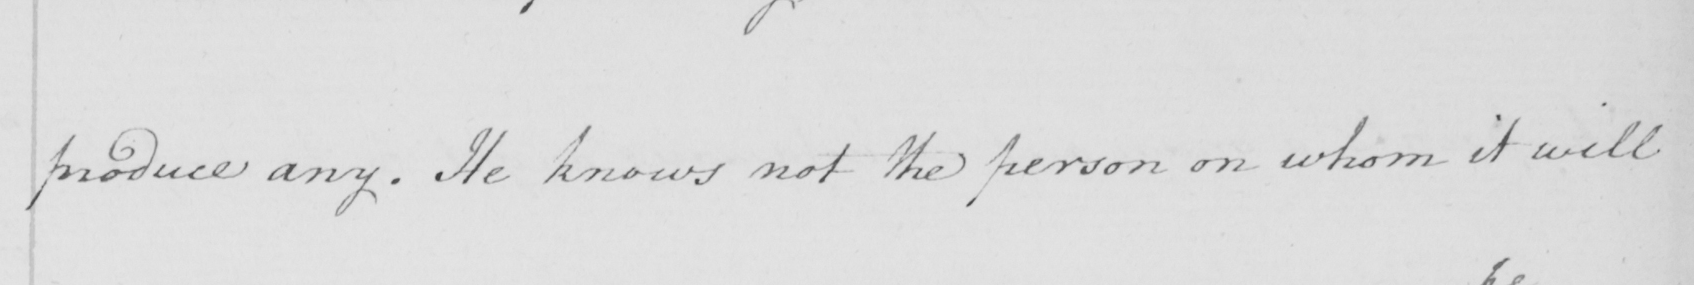Can you tell me what this handwritten text says? produce any . He knows not the person on whom it will 